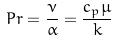Convert formula to latex. <formula><loc_0><loc_0><loc_500><loc_500>P r = \frac { \nu } { \alpha } = \frac { c _ { p } \mu } { k }</formula> 